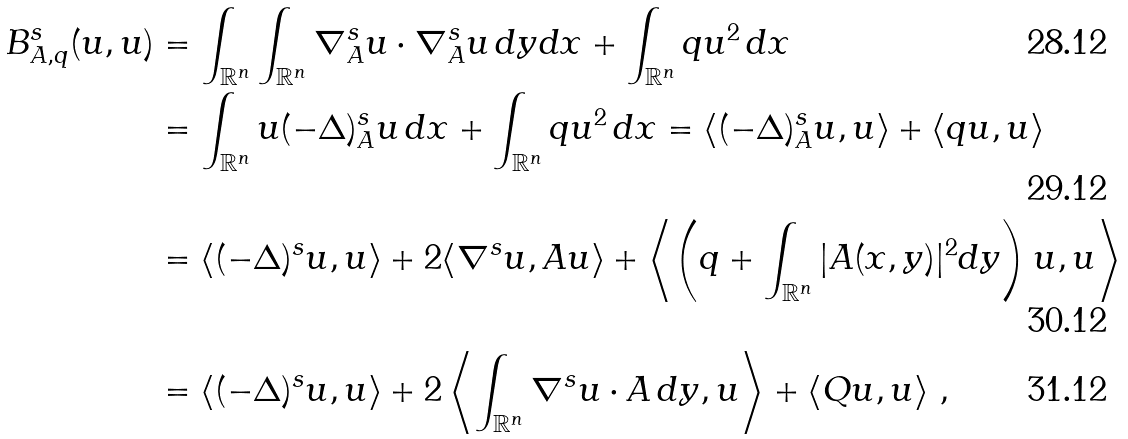Convert formula to latex. <formula><loc_0><loc_0><loc_500><loc_500>B ^ { s } _ { A , q } ( u , u ) & = \int _ { \mathbb { R } ^ { n } } \int _ { \mathbb { R } ^ { n } } \nabla ^ { s } _ { A } u \cdot \nabla ^ { s } _ { A } u \, d y d x + \int _ { \mathbb { R } ^ { n } } q u ^ { 2 } \, d x \\ & = \int _ { \mathbb { R } ^ { n } } u ( - \Delta ) ^ { s } _ { A } u \, d x + \int _ { \mathbb { R } ^ { n } } q u ^ { 2 } \, d x = \langle ( - \Delta ) ^ { s } _ { A } u , u \rangle + \langle q u , u \rangle \\ & = \langle ( - \Delta ) ^ { s } u , u \rangle + 2 \langle \nabla ^ { s } u , A u \rangle + \left \langle \left ( q + \int _ { \mathbb { R } ^ { n } } | A ( x , y ) | ^ { 2 } d y \right ) u , u \right \rangle \\ & = \langle ( - \Delta ) ^ { s } u , u \rangle + 2 \left \langle \int _ { \mathbb { R } ^ { n } } \nabla ^ { s } u \cdot A \, d y , u \right \rangle + \left \langle Q u , u \right \rangle \, ,</formula> 